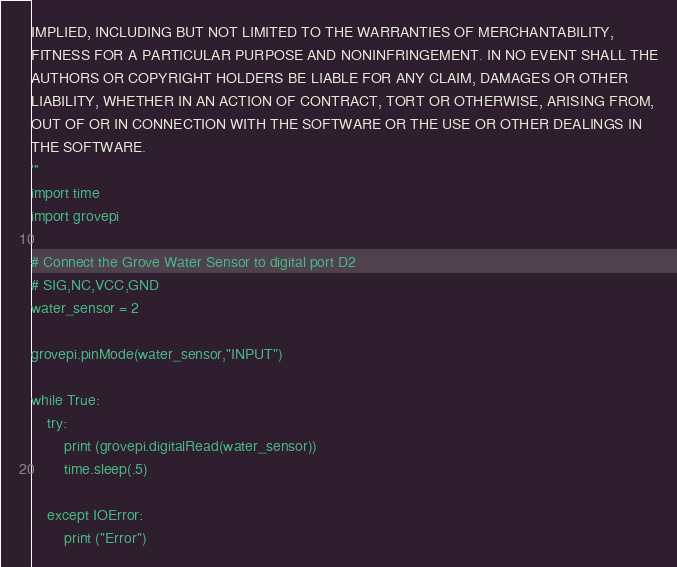Convert code to text. <code><loc_0><loc_0><loc_500><loc_500><_Python_>IMPLIED, INCLUDING BUT NOT LIMITED TO THE WARRANTIES OF MERCHANTABILITY,
FITNESS FOR A PARTICULAR PURPOSE AND NONINFRINGEMENT. IN NO EVENT SHALL THE
AUTHORS OR COPYRIGHT HOLDERS BE LIABLE FOR ANY CLAIM, DAMAGES OR OTHER
LIABILITY, WHETHER IN AN ACTION OF CONTRACT, TORT OR OTHERWISE, ARISING FROM,
OUT OF OR IN CONNECTION WITH THE SOFTWARE OR THE USE OR OTHER DEALINGS IN
THE SOFTWARE.
'''
import time
import grovepi

# Connect the Grove Water Sensor to digital port D2
# SIG,NC,VCC,GND
water_sensor = 2

grovepi.pinMode(water_sensor,"INPUT")

while True:
    try:
        print (grovepi.digitalRead(water_sensor))
        time.sleep(.5)

    except IOError:
        print ("Error")
</code> 